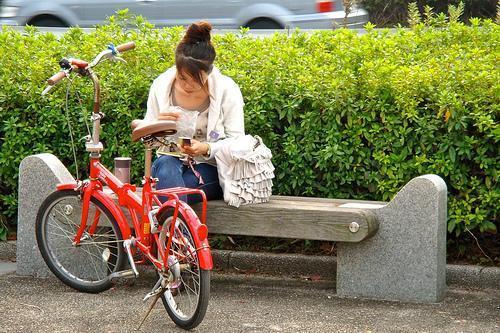How many cars are there?
Give a very brief answer. 1. How many pizzas are in the photo?
Give a very brief answer. 0. 